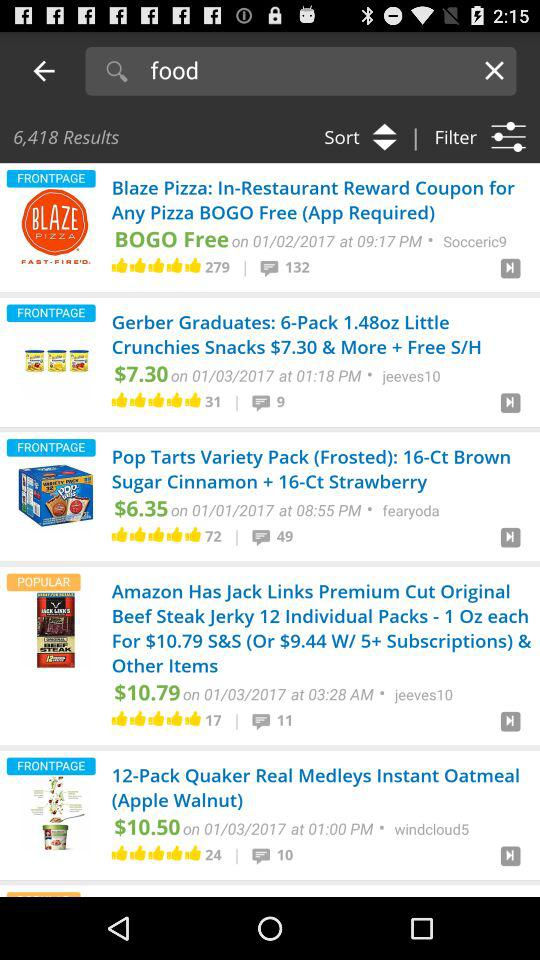What is the price of the "Pop Tarts Variety Pack"? The price of the "Pop Tarts Variety Pack" is $6.35. 